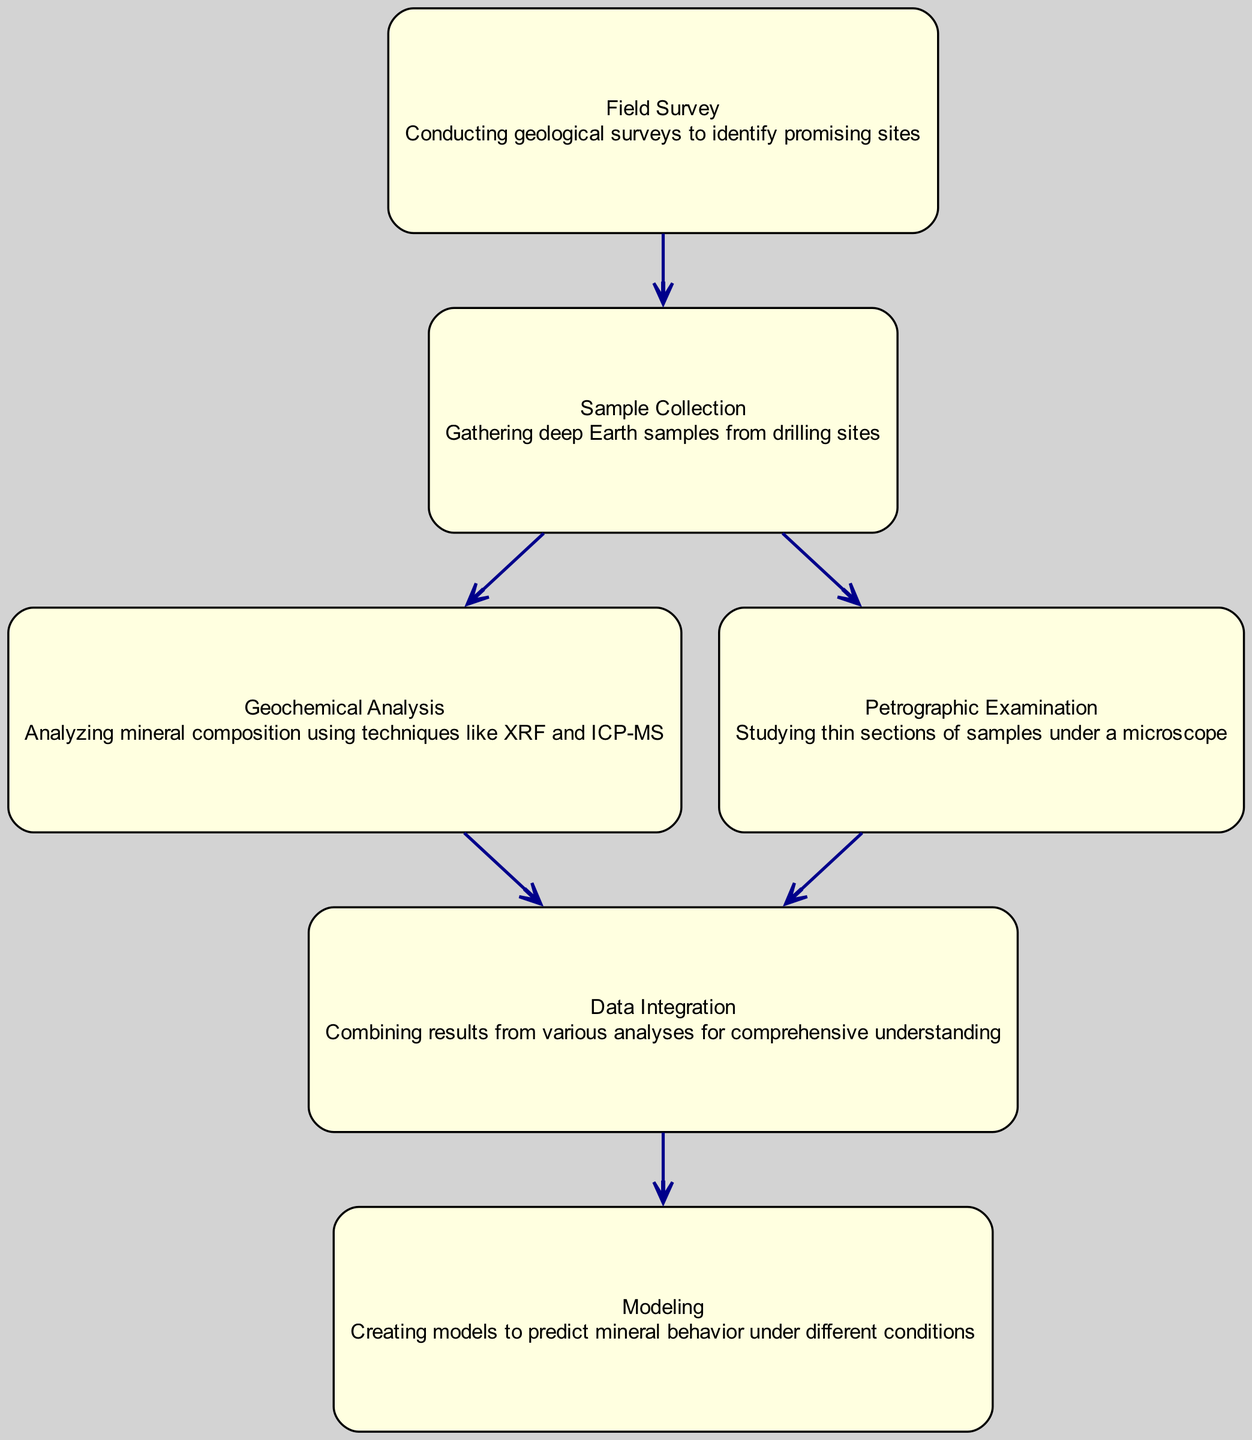What is the starting point for data collection? The diagram indicates that the starting point for data collection is "Field Survey," which is the first node connected to the "Sample Collection" node.
Answer: Field Survey How many nodes are present in the diagram? By counting the different nodes in the diagram, we find there are six nodes: Field Survey, Sample Collection, Geochemical Analysis, Petrographic Examination, Data Integration, and Modeling.
Answer: Six Which analysis follows directly after Sample Collection? The diagram shows that "Geochemical Analysis" and "Petrographic Examination" both follow directly from "Sample Collection." The flow leads to two separate analyses that occur simultaneously.
Answer: Geochemical Analysis, Petrographic Examination What is the final step in the data processing flow? The last node connected in the diagram is "Modeling," which indicates that it is the final step after integrating the data from previous analyses.
Answer: Modeling Which two analysis methods contribute to Data Integration? According to the diagram, both "Geochemical Analysis" and "Petrographic Examination" direct their results to the "Data Integration" node, showing that both are essential for this step.
Answer: Geochemical Analysis, Petrographic Examination How many edges connect all the nodes together? Counting the edges that link the nodes, we find there are five edges connecting the various processes, representing the flow of data collection steps to result in integrated data for modeling.
Answer: Five What must occur before any analysis can be conducted? The "Sample Collection" node is a prerequisite for both "Geochemical Analysis" and "Petrographic Examination," meaning that sample collection must happen before these analyses can take place.
Answer: Sample Collection Which step in the process involves combining results? The process marked by "Data Integration" signifies that this step is about combining results from the preceding analyses to form a comprehensive understanding.
Answer: Data Integration 